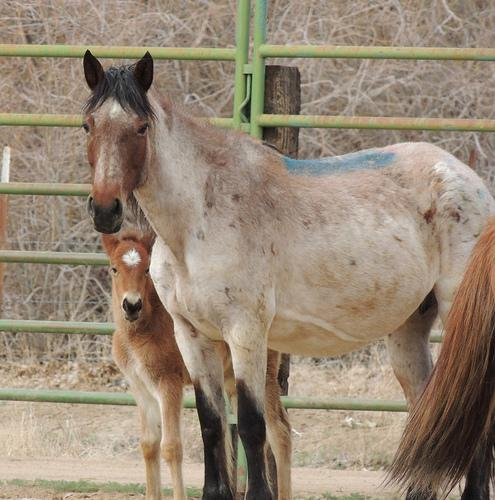Provide a concise account of the main object in the picture along with its attributes and actions. A white adult horse and a brown young one are the main subjects in the image, both looking into the open air in a dry grass field. Explain the primary focus of the image along with any distinctive features. The main focus is on a white horse and its brown young one, attentively staring in the open air while standing in a dry grass field. Identify the main subjects in the image and their attributes. The image contains a white adult horse and a brown young horse, both with distinctive spots and markings, looking into the open air. Summarize the image and provide details about the main subject and its surroundings. The image showcases a white horse and a brown young horse staring in the open air, surrounded by dry grass fields and a rusted green fence. Give a succinct overview of the main object in the image and its characteristics. The image primarily features a white adult horse along with a brown young one, both attentively gazing in the open air. Describe the central subjects of the image and their appearance. The central subjects are a white adult horse and a brown young one. They appear to be staring into open air in a grassy field. Briefly describe the scene depicted in the image along with the features of the main subjects. The image portrays a horse and its young one in a dry grass field, with the adult horse being white in color and the young one being brown. Mention the key elements in the image and their characteristics. The image features an adult horse, a young horse, and a fence. The adult horse is white, the young one is brown, and the fence is rusted green. Write a short description of the main objects in the image and their actions. The photo captures two horses, an adult and its brown offspring, gazing into the distance while surrounded by a grassy field and a rusted green fence. Provide a brief summary of the focal point of the image and its appearance. A horse and its young one are in the center of the image, with the adult being white and the young one being brown, both staring into open air. 